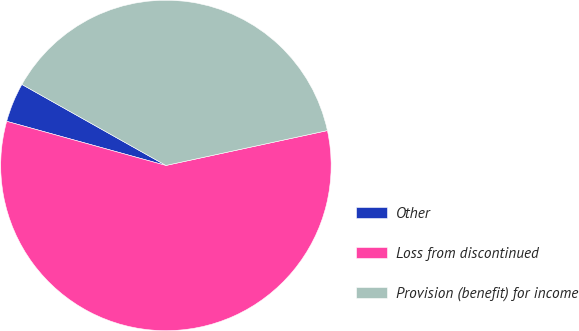Convert chart to OTSL. <chart><loc_0><loc_0><loc_500><loc_500><pie_chart><fcel>Other<fcel>Loss from discontinued<fcel>Provision (benefit) for income<nl><fcel>3.85%<fcel>57.69%<fcel>38.46%<nl></chart> 